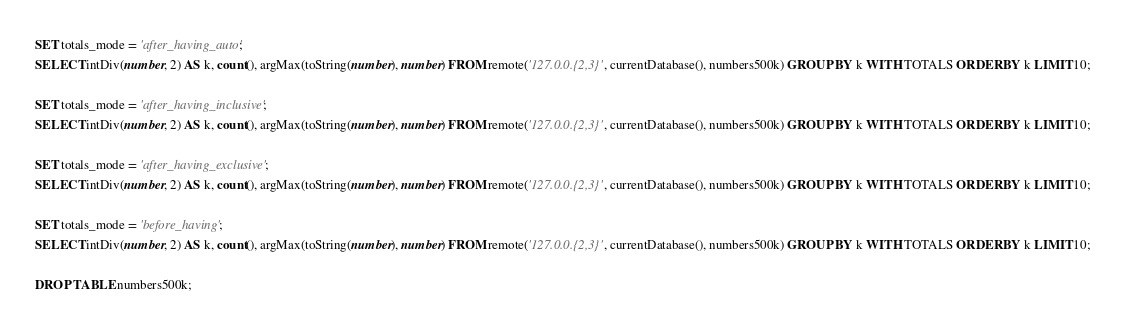Convert code to text. <code><loc_0><loc_0><loc_500><loc_500><_SQL_>SET totals_mode = 'after_having_auto';
SELECT intDiv(number, 2) AS k, count(), argMax(toString(number), number) FROM remote('127.0.0.{2,3}', currentDatabase(), numbers500k) GROUP BY k WITH TOTALS ORDER BY k LIMIT 10;

SET totals_mode = 'after_having_inclusive';
SELECT intDiv(number, 2) AS k, count(), argMax(toString(number), number) FROM remote('127.0.0.{2,3}', currentDatabase(), numbers500k) GROUP BY k WITH TOTALS ORDER BY k LIMIT 10;

SET totals_mode = 'after_having_exclusive';
SELECT intDiv(number, 2) AS k, count(), argMax(toString(number), number) FROM remote('127.0.0.{2,3}', currentDatabase(), numbers500k) GROUP BY k WITH TOTALS ORDER BY k LIMIT 10;

SET totals_mode = 'before_having';
SELECT intDiv(number, 2) AS k, count(), argMax(toString(number), number) FROM remote('127.0.0.{2,3}', currentDatabase(), numbers500k) GROUP BY k WITH TOTALS ORDER BY k LIMIT 10;

DROP TABLE numbers500k;
</code> 